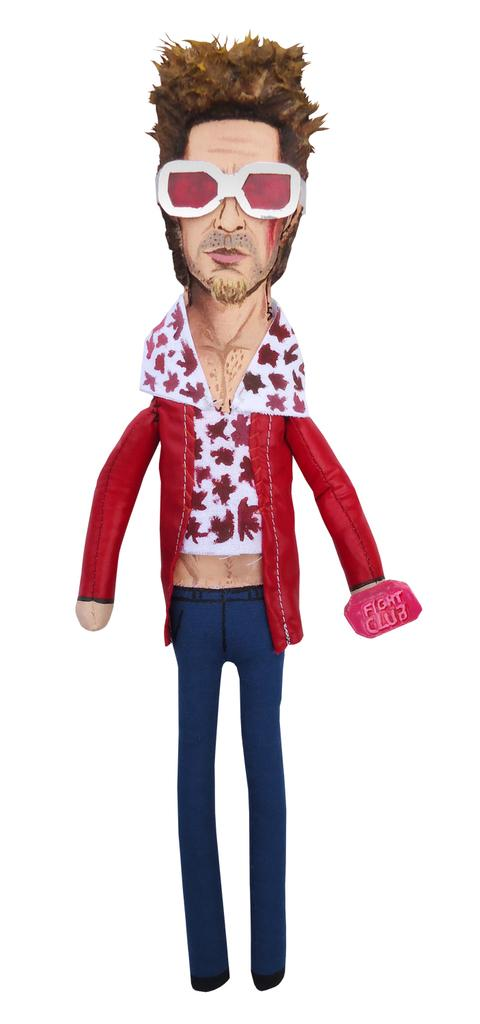What object can be seen in the image? There is a toy in the image. What color is the background of the image? The background of the image is white. What is the name of the toy in the image? The provided facts do not mention the name of the toy, so it cannot be determined from the image. 